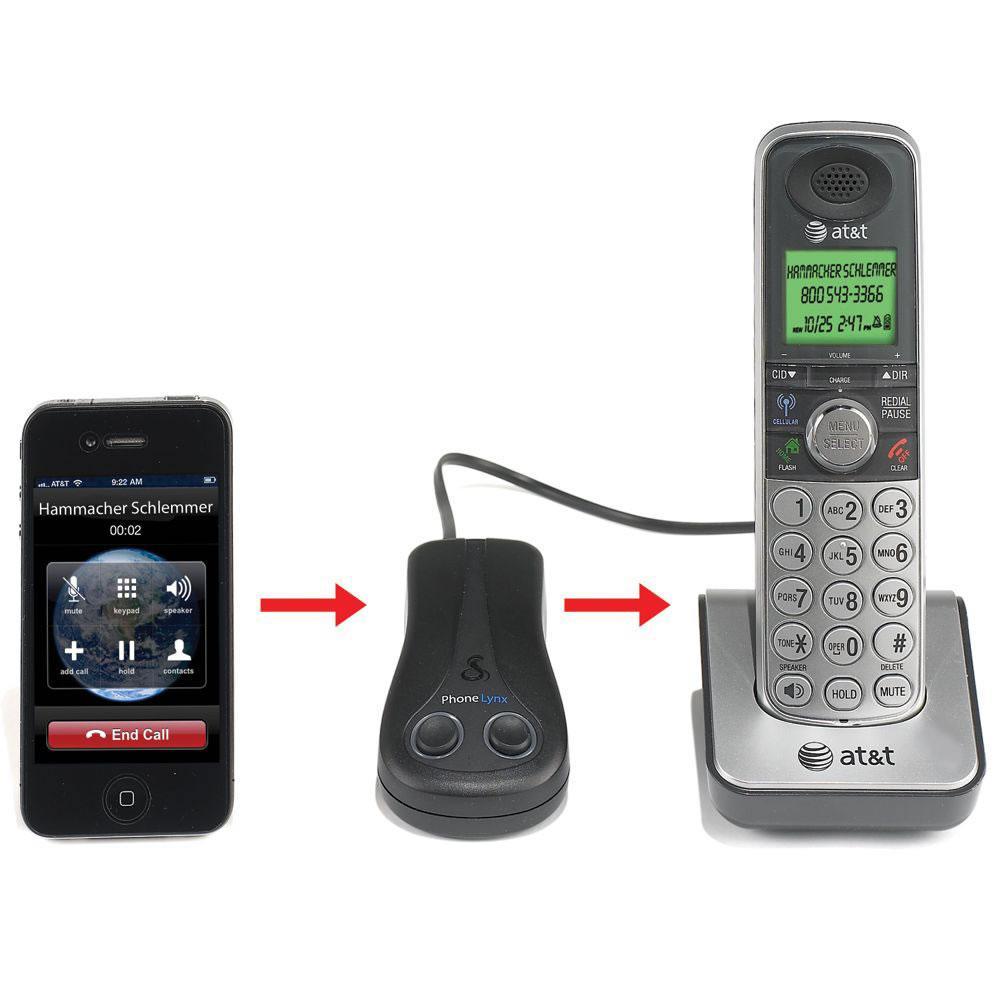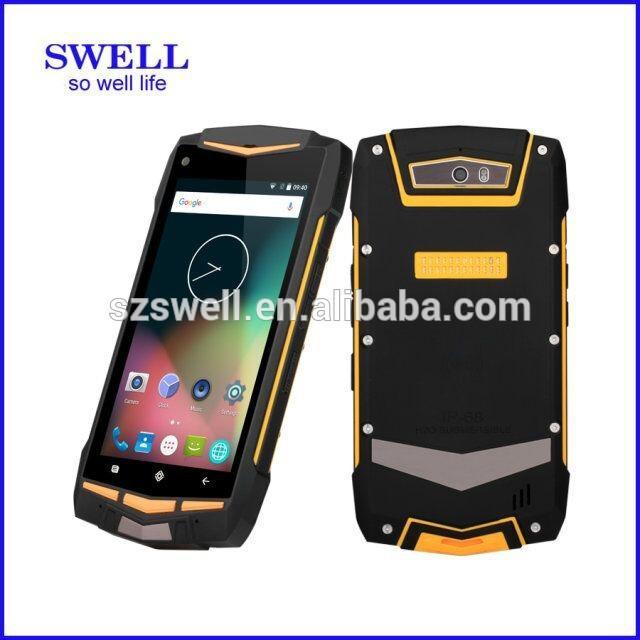The first image is the image on the left, the second image is the image on the right. Assess this claim about the two images: "The right image contains no more than three cell phones.". Correct or not? Answer yes or no. Yes. The first image is the image on the left, the second image is the image on the right. For the images shown, is this caption "There is a non smart phone in a charger." true? Answer yes or no. Yes. 